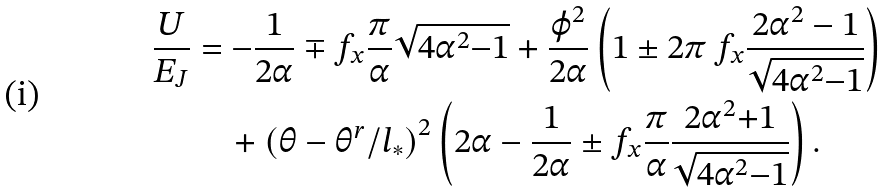Convert formula to latex. <formula><loc_0><loc_0><loc_500><loc_500>\frac { U } { E _ { J } } & = - \frac { 1 } { 2 \alpha } \mp f _ { x } \frac { \pi } { \alpha } \sqrt { 4 \alpha ^ { 2 } { - } 1 } + \frac { \varphi ^ { 2 } } { 2 \alpha } \left ( 1 \pm 2 \pi \, f _ { x } \frac { 2 \alpha ^ { 2 } - 1 } { \sqrt { 4 \alpha ^ { 2 } { - } 1 } } \right ) \\ & \quad + { ( \theta - \theta ^ { r } / l _ { * } ) } ^ { 2 } \left ( 2 \alpha - \frac { 1 } { 2 \alpha } \pm f _ { x } \frac { \pi } { \alpha } \frac { 2 \alpha ^ { 2 } { + } 1 } { \sqrt { 4 \alpha ^ { 2 } { - } 1 } } \right ) .</formula> 